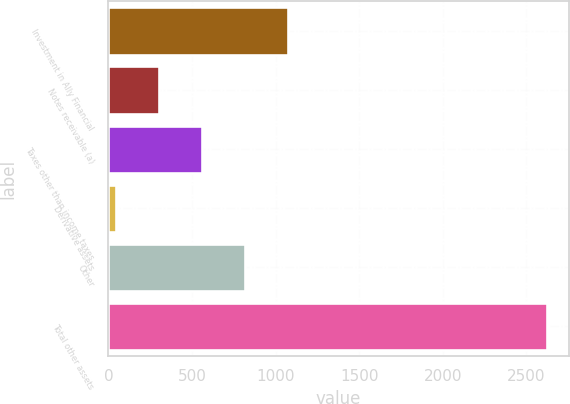<chart> <loc_0><loc_0><loc_500><loc_500><bar_chart><fcel>Investment in Ally Financial<fcel>Notes receivable (a)<fcel>Taxes other than income taxes<fcel>Derivative assets<fcel>Other<fcel>Total other assets<nl><fcel>1075.6<fcel>301.9<fcel>559.8<fcel>44<fcel>817.7<fcel>2623<nl></chart> 